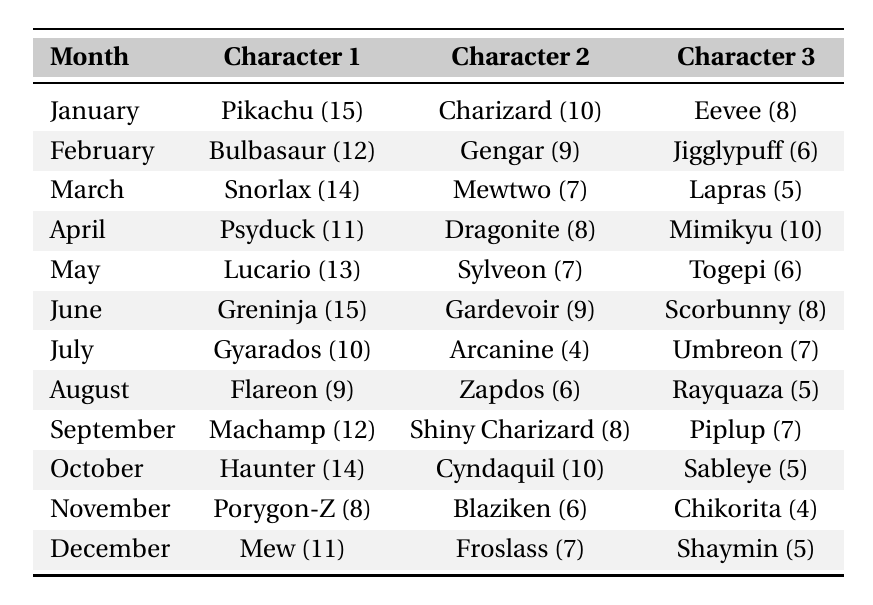What character had the highest commission requests in January? In January, the character with the highest quantity of requests is Pikachu, which received 15 requests.
Answer: Pikachu Which month had the least total commission requests? To find the month with the least total requests, I need to sum the requests for each month. For November, the total is (8 + 6 + 4) = 18 requests, which is the lowest total.
Answer: November How many requests did Greninja receive in June? The table shows that Greninja had 15 requests in June.
Answer: 15 What is the total number of requests for Charizard in January and Shiny Charizard in September? Charizard received 10 requests in January and Shiny Charizard received 8 in September. Adding these gives 10 + 8 = 18 requests in total.
Answer: 18 Was there a character that had more than 14 requests in any month? Yes, Pikachu and Greninja both had more than 14 requests, with Pikachu at 15 in January and Greninja at 15 in June.
Answer: Yes What is the average number of requests received by characters in October? In October, the character requests are Haunter (14), Cyndaquil (10), and Sableye (5). The total requests are 14 + 10 + 5 = 29, and there are 3 characters. The average is 29 / 3 = 9.67.
Answer: 9.67 Which character had the highest total requests over the year? To determine this, I need to add up the requests for each character over all months. Pikachu has 15, Charizard 10, Eevee 8, and onwards. After doing the calculations, Greninja has the highest total of 15 requests in June.
Answer: Greninja What is the difference in requests between the most requested character in June and the least requested character in July? Greninja had 15 requests in June (highest), while Arcanine had 4 requests in July (lowest). The difference is 15 - 4 = 11.
Answer: 11 How many characters were requested more than 10 times throughout the year? Counting the characters requested more than 10 times: Pikachu (15), Snorlax (14), Greninja (15), and Haunter (14). This gives a total of 4 characters.
Answer: 4 In which month did Mew have its requests? According to the table, Mew had its requests in December, with a total of 11.
Answer: December 